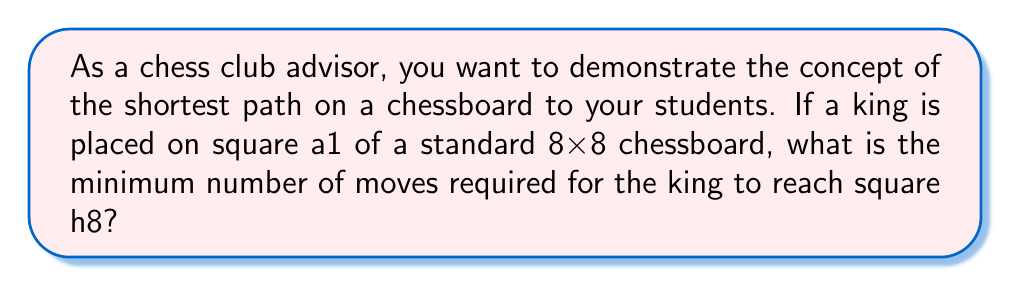Help me with this question. To solve this problem, we need to understand the movement of a king on a chessboard and apply the concept of the shortest path.

1. King's movement: A king can move one square in any direction (horizontally, vertically, or diagonally).

2. Chessboard layout: An 8x8 chessboard has squares labeled from a1 to h8, where letters (a-h) represent columns and numbers (1-8) represent rows.

3. Starting and ending points:
   - Start: a1 (bottom-left corner)
   - End: h8 (top-right corner)

4. Shortest path: The shortest path will be a diagonal line from a1 to h8, as moving diagonally allows the king to advance in both the horizontal and vertical directions simultaneously.

5. Calculating the number of moves:
   - To move from a1 to h8, the king needs to move 7 squares right and 7 squares up.
   - Each diagonal move covers one square right and one square up.
   - Therefore, the number of moves required is equal to the number of diagonal moves.

6. Mathematical representation:
   Let $x$ be the number of moves required.
   $$x = \max(\text{horizontal distance}, \text{vertical distance})$$
   $$x = \max(8-1, 8-1) = \max(7, 7) = 7$$

Thus, the minimum number of moves required for the king to reach h8 from a1 is 7.

[asy]
size(200);
for(int i=0; i<8; ++i)
  for(int j=0; j<8; ++j)
    fill((i+j)%2==0 ? white : gray, scale(1)*square((i,j)));
draw((0,0)--(7,7), red+1);
label("a1", (0,0), SW);
label("h8", (7,7), NE);
[/asy]
Answer: 7 moves 